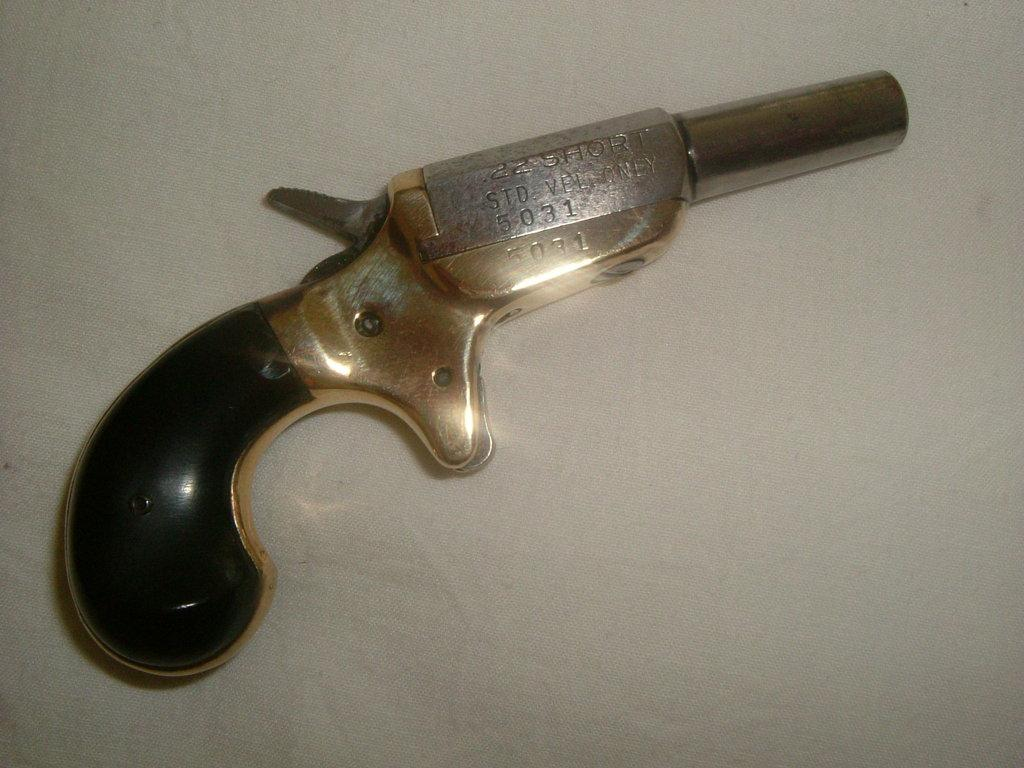What object is present in the image that resembles a weapon? There is a small gun in the image. What colors can be seen on the gun? The gun has a golden and black color. What is the gun placed on in the image? The gun is placed on a white cloth. Can you see a ghost interacting with the gun in the image? There is no ghost present in the image, and the gun is not interacting with any other objects or entities. 